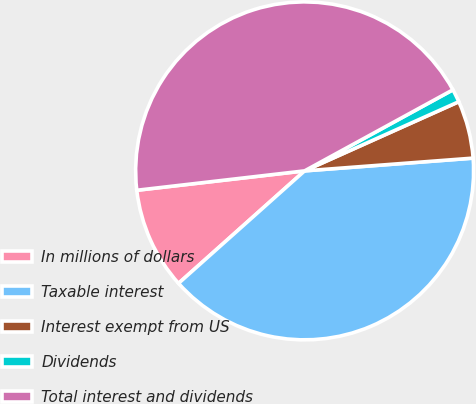<chart> <loc_0><loc_0><loc_500><loc_500><pie_chart><fcel>In millions of dollars<fcel>Taxable interest<fcel>Interest exempt from US<fcel>Dividends<fcel>Total interest and dividends<nl><fcel>9.76%<fcel>39.61%<fcel>5.51%<fcel>1.25%<fcel>43.87%<nl></chart> 